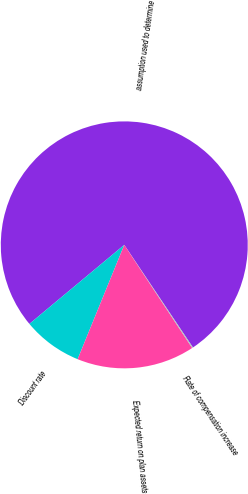Convert chart. <chart><loc_0><loc_0><loc_500><loc_500><pie_chart><fcel>assumption used to determine<fcel>Discount rate<fcel>Expected return on plan assets<fcel>Rate of compensation increase<nl><fcel>76.67%<fcel>7.78%<fcel>15.43%<fcel>0.12%<nl></chart> 